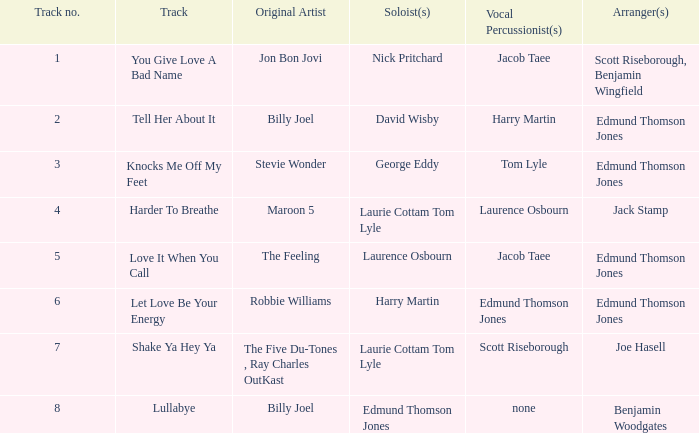Who were the original artist(s) for track number 6? Robbie Williams. 